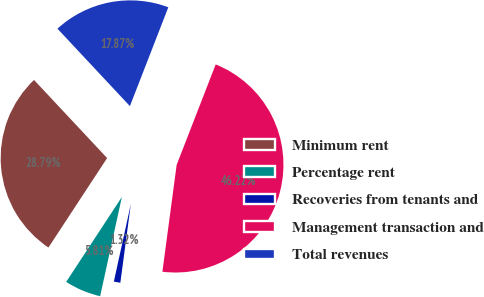Convert chart to OTSL. <chart><loc_0><loc_0><loc_500><loc_500><pie_chart><fcel>Minimum rent<fcel>Percentage rent<fcel>Recoveries from tenants and<fcel>Management transaction and<fcel>Total revenues<nl><fcel>28.79%<fcel>5.81%<fcel>1.32%<fcel>46.22%<fcel>17.87%<nl></chart> 